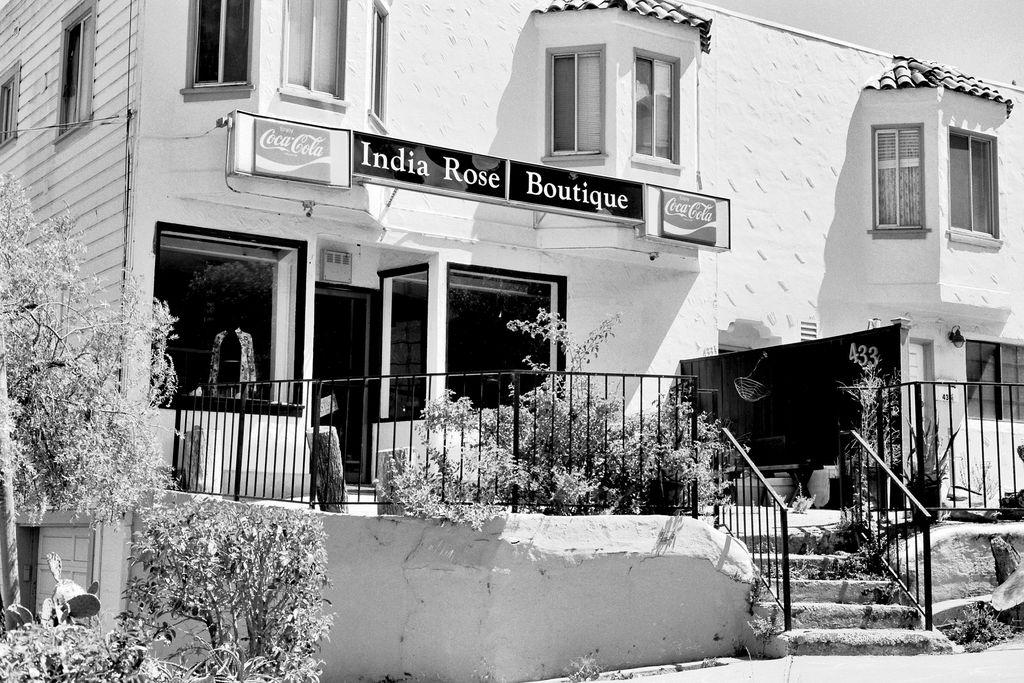What is the color scheme of the image? The image is black and white. What type of vegetation can be seen in the image? There is a tree and plants in the image. What architectural feature is present in the image? There are steps in the image. What is used for support or safety in the image? There are railings in the image. What type of structure is visible in the image? There is a building in the image. What part of the natural environment is visible in the image? The sky is visible in the image. What type of advertisement is present in the image? There are hoardings in the image. Can you tell me how many balls are rolling down the street in the image? There is no street or balls present in the image; it features a black and white scene with a tree, plants, steps, railings, a building, the sky, and hoardings. 